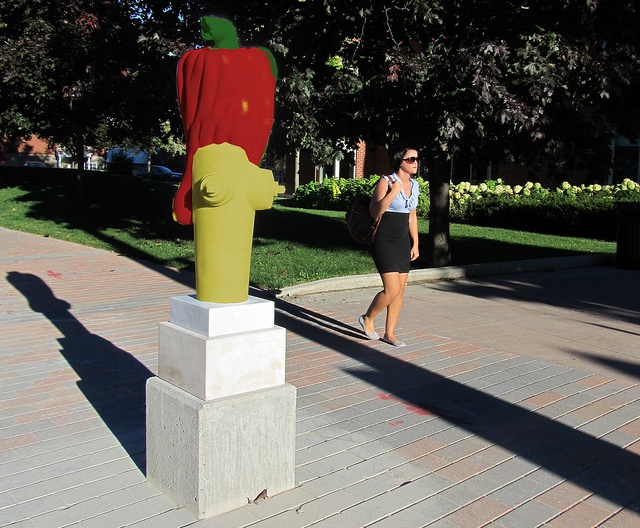Describe the objects in this image and their specific colors. I can see fire hydrant in black, khaki, and olive tones, people in black, tan, and lavender tones, handbag in black, brown, maroon, and gray tones, car in black, navy, blue, and darkblue tones, and car in black and navy tones in this image. 